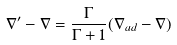Convert formula to latex. <formula><loc_0><loc_0><loc_500><loc_500>\nabla ^ { \prime } - \nabla = \frac { \Gamma } { \Gamma + 1 } ( \nabla _ { a d } - \nabla ) \,</formula> 